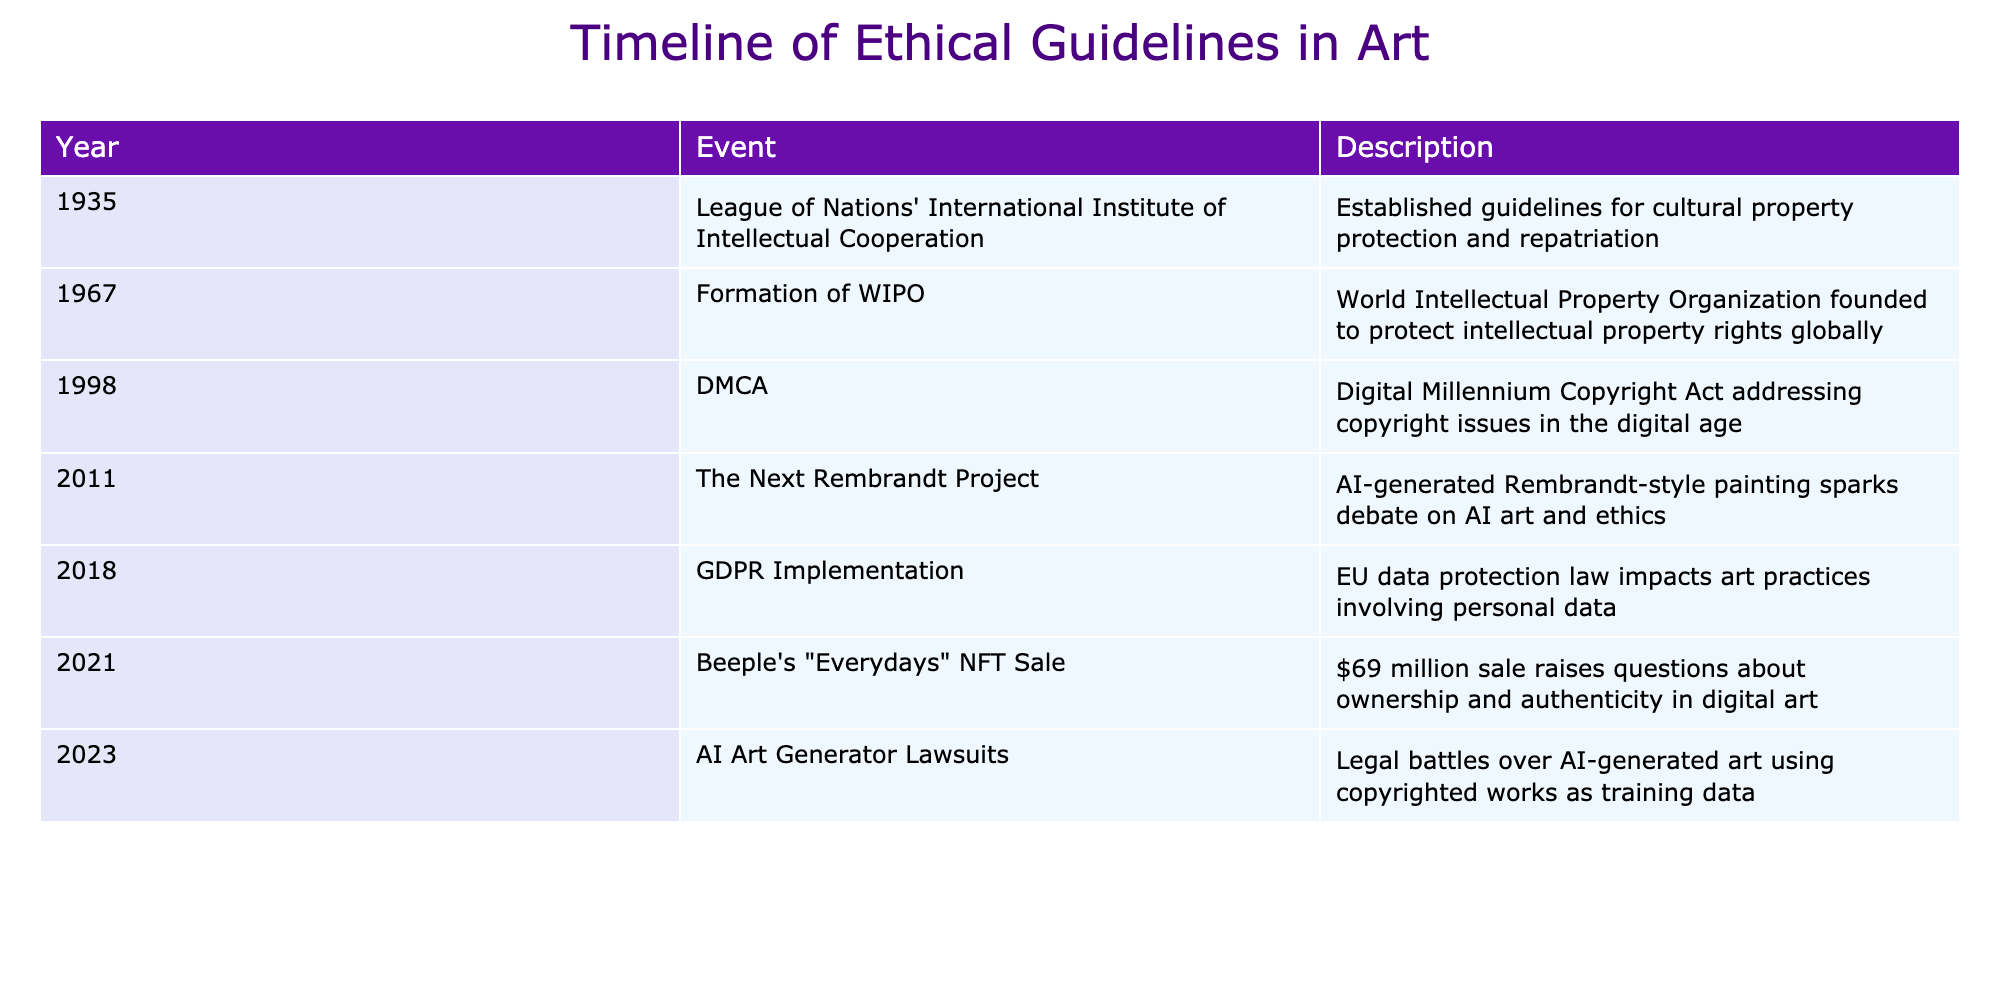What year was the DMCA enacted? The DMCA, or Digital Millennium Copyright Act, is listed in the table under the year 1998.
Answer: 1998 What was the main focus of the League of Nations' initiative in 1935? The event in 1935 mentions that the League of Nations' International Institute of Intellectual Cooperation established guidelines for cultural property protection and repatriation.
Answer: Cultural property protection and repatriation Which milestone raised questions about ownership in digital art? The table notes that the sale of Beeple's "Everydays" NFT for $69 million in 2021 raised questions about ownership and authenticity in digital art.
Answer: Beeple's "Everydays" NFT Sale In what year did AI-generated art become a legal issue? The table states that the legal battles over AI-generated art occurred in 2023, specifically involving copyrighted works used as training data.
Answer: 2023 Was the GDPR implementation in 2018 related to personal data in art practices? The description in the table for 2018 confirms that the GDPR implementation impacts art practices involving personal data.
Answer: Yes What is the difference in years between the formation of WIPO and the DMCA? The formation of WIPO occurred in 1967 and the DMCA was enacted in 1998. Therefore, the difference is 1998 - 1967 = 31 years.
Answer: 31 years What ethical issues did The Next Rembrandt Project in 2011 address? The table mentions that the project sparked debate on AI art and ethics, signifying it addressed ethical issues regarding artistic creation through AI.
Answer: AI art and ethics Did any event listed in the table occur before 2000? Yes, both the League of Nations' initiative in 1935 and the formation of WIPO in 1967 occurred before the year 2000.
Answer: Yes How many milestones in the table involved international cooperation or guidelines? The table lists three events that can be classified under international cooperation or guidelines: the League of Nations' event in 1935, the formation of WIPO in 1967, and the GDPR implementation in 2018.
Answer: Three 